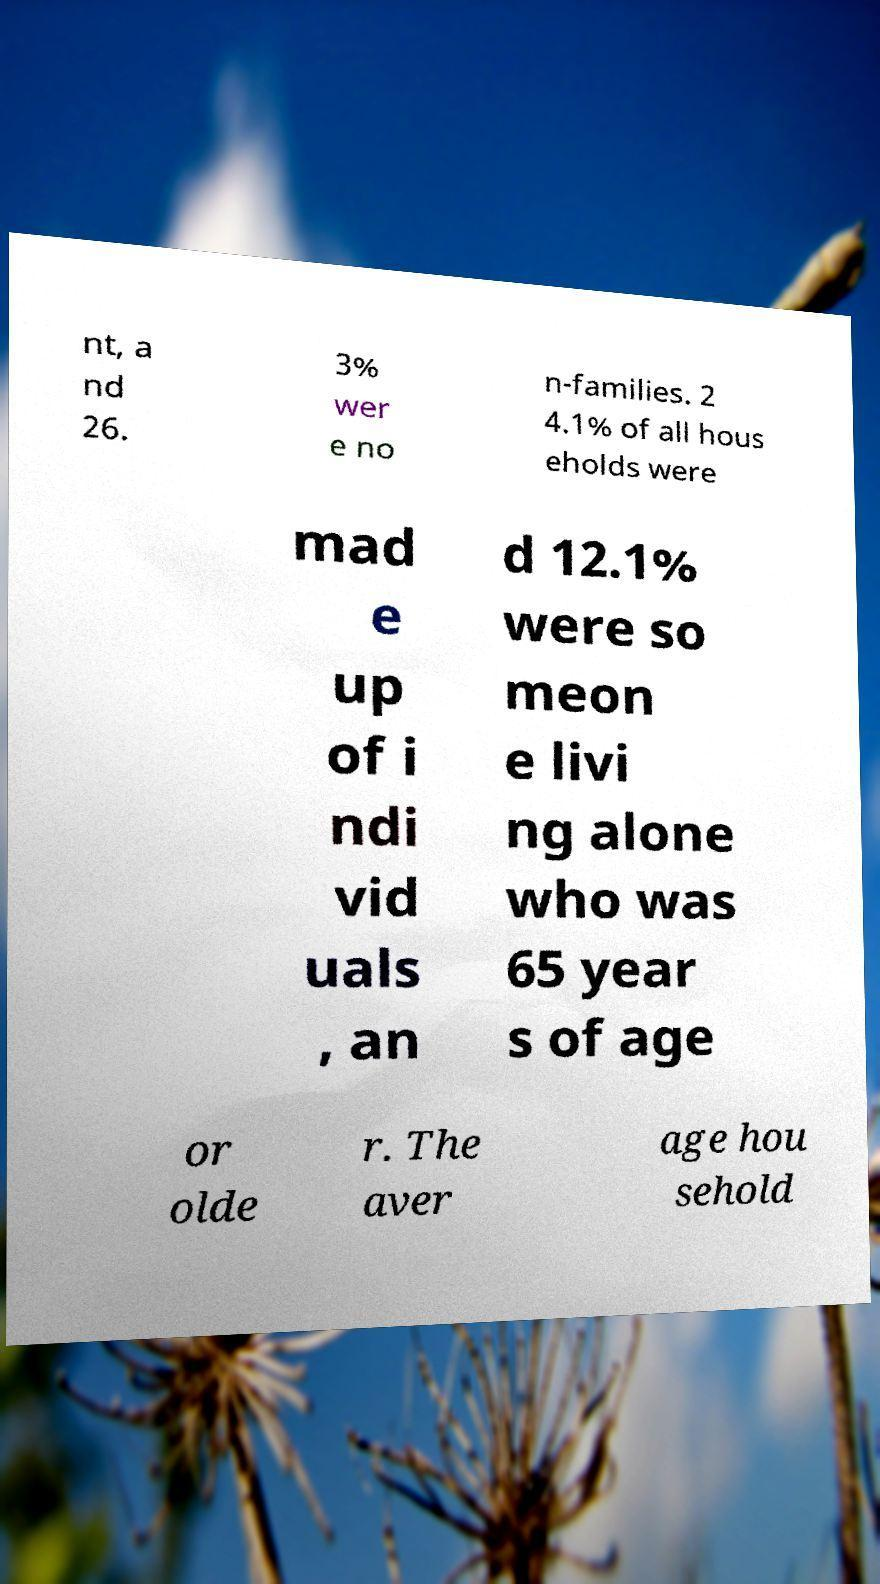Can you accurately transcribe the text from the provided image for me? nt, a nd 26. 3% wer e no n-families. 2 4.1% of all hous eholds were mad e up of i ndi vid uals , an d 12.1% were so meon e livi ng alone who was 65 year s of age or olde r. The aver age hou sehold 